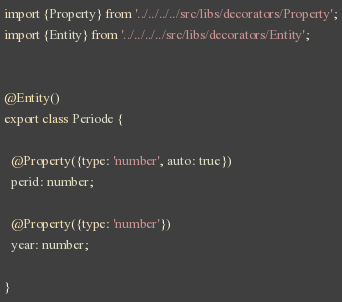Convert code to text. <code><loc_0><loc_0><loc_500><loc_500><_TypeScript_>import {Property} from '../../../../src/libs/decorators/Property';
import {Entity} from '../../../../src/libs/decorators/Entity';


@Entity()
export class Periode {

  @Property({type: 'number', auto: true})
  perid: number;

  @Property({type: 'number'})
  year: number;

}
</code> 